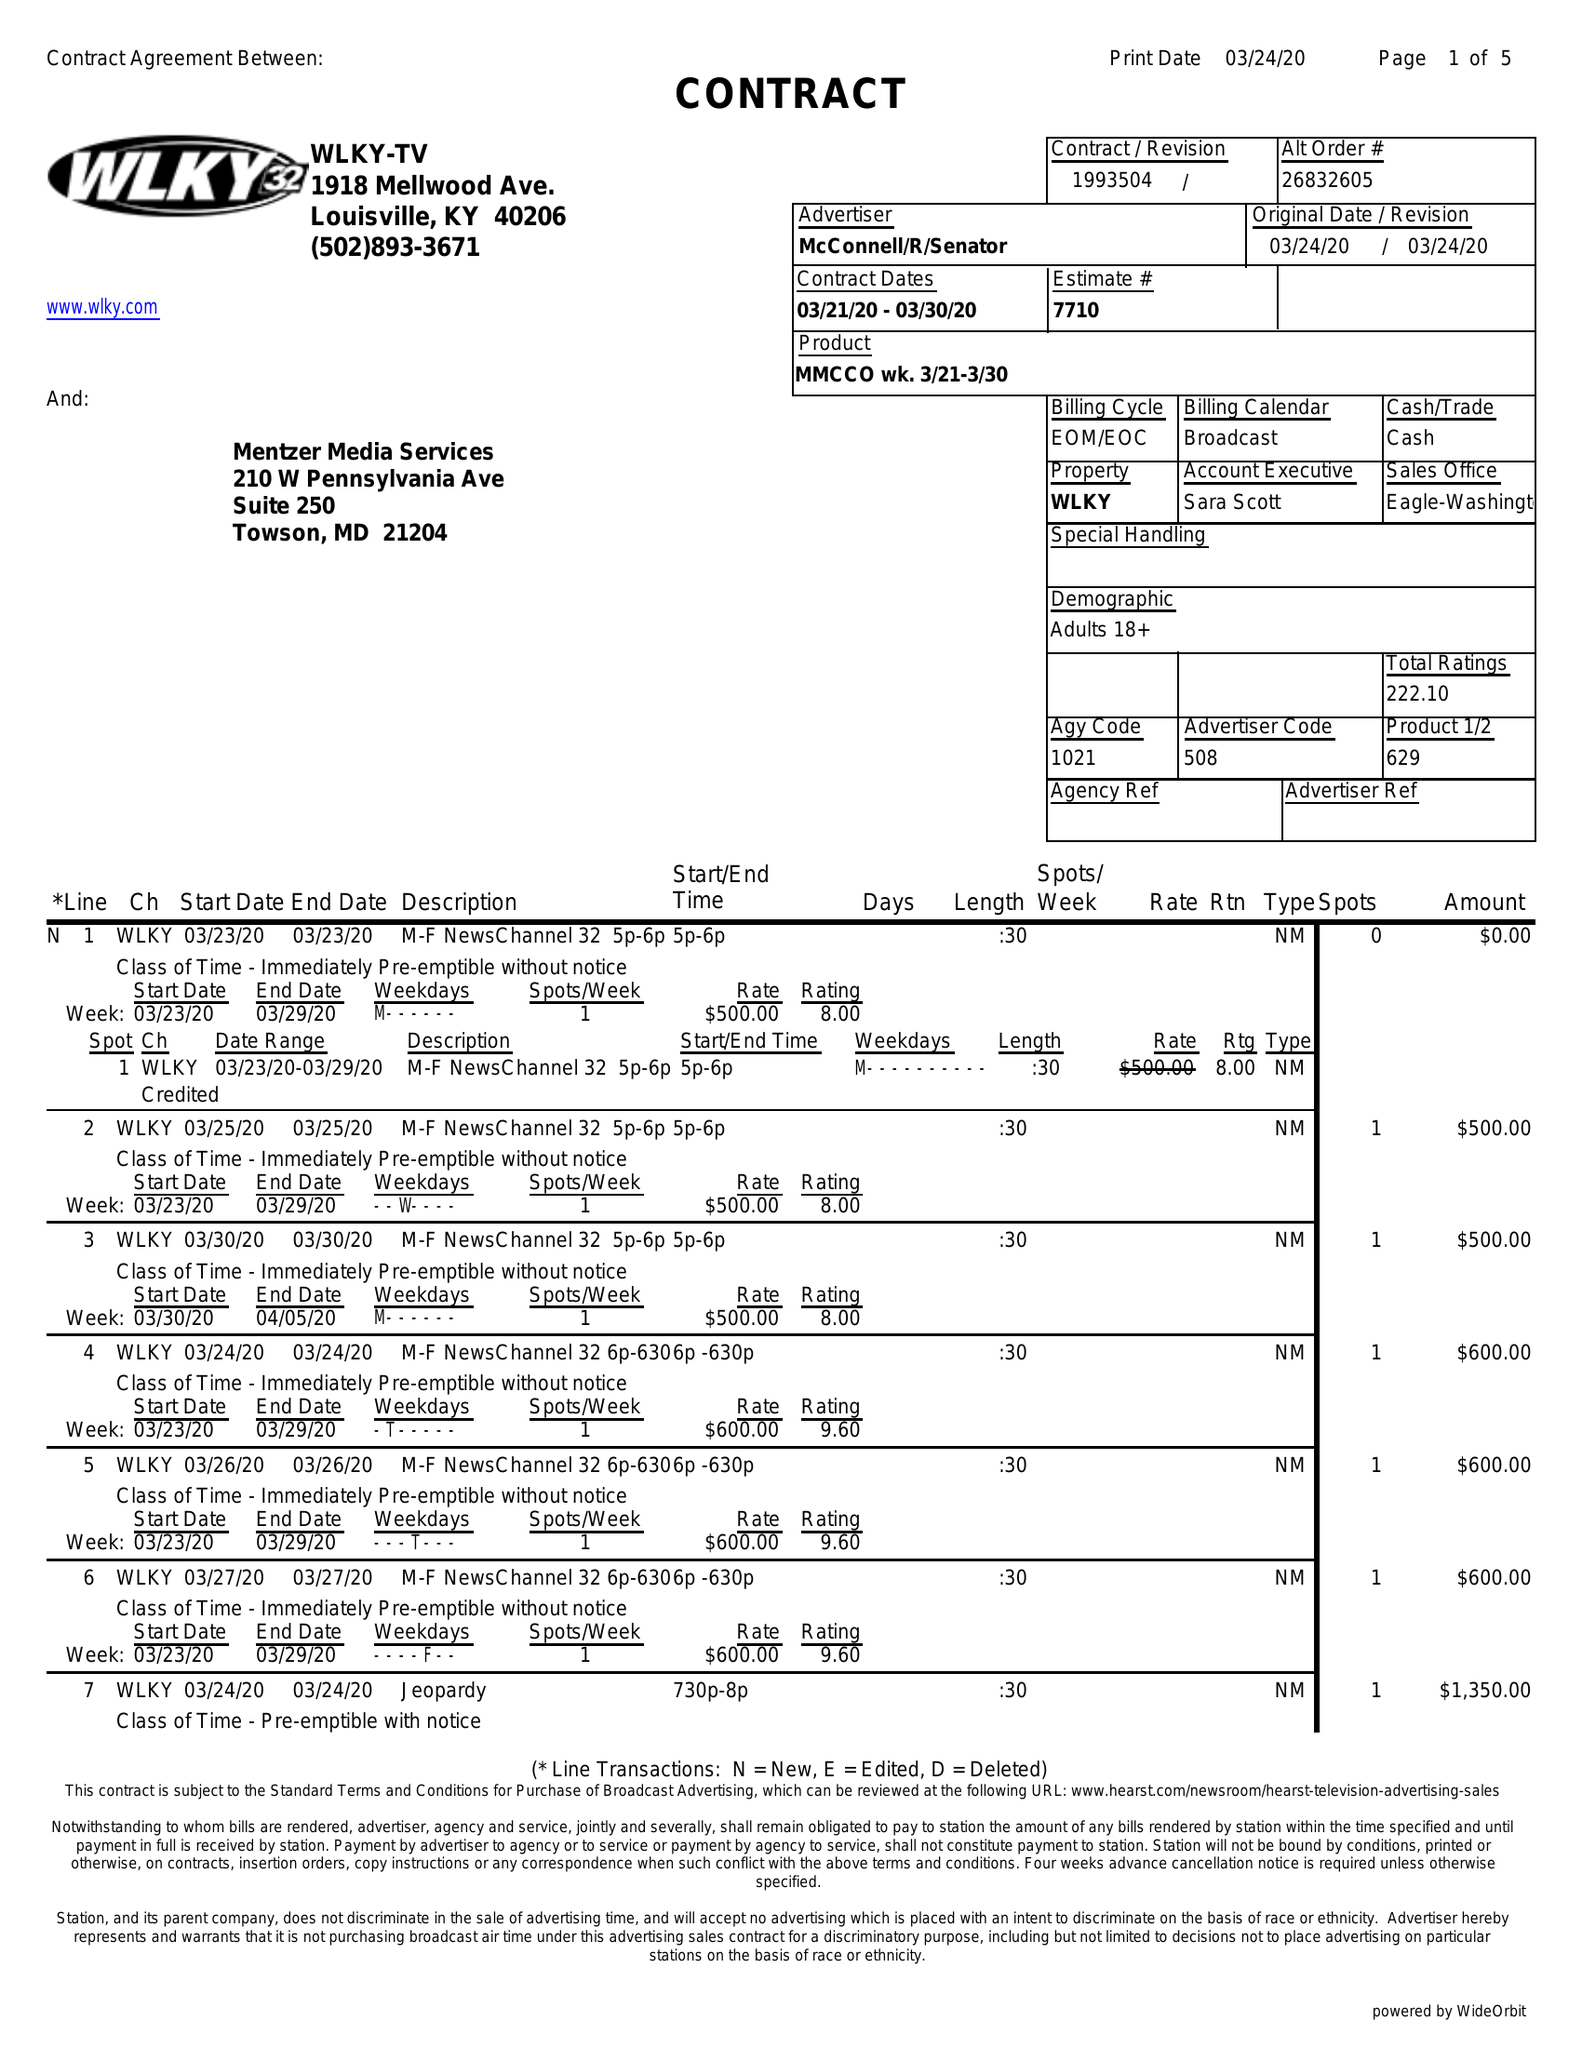What is the value for the contract_num?
Answer the question using a single word or phrase. 1993504 